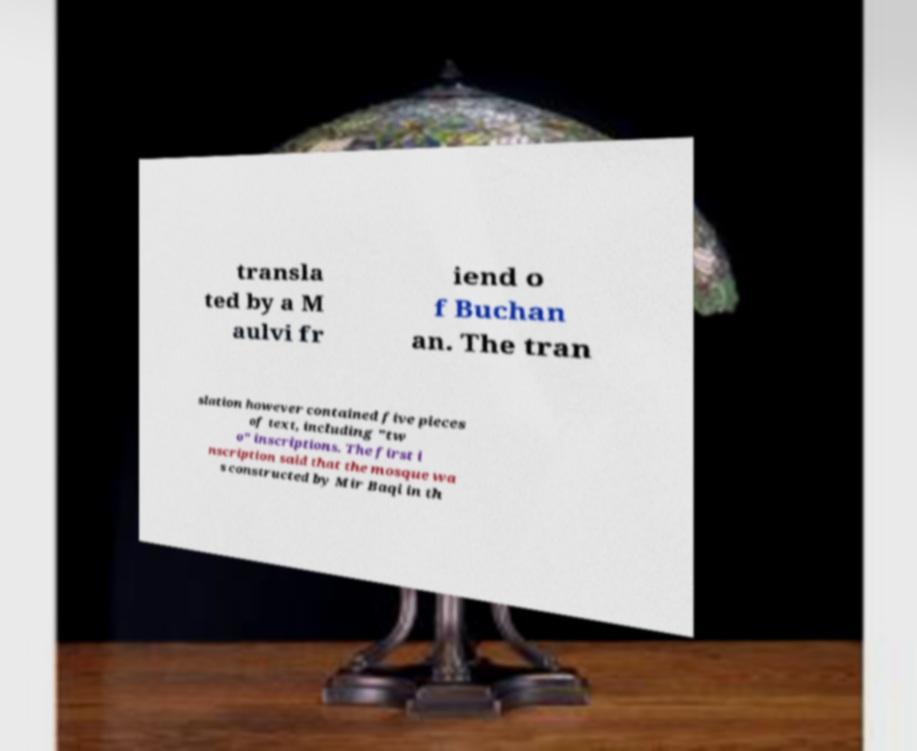Could you extract and type out the text from this image? transla ted by a M aulvi fr iend o f Buchan an. The tran slation however contained five pieces of text, including "tw o" inscriptions. The first i nscription said that the mosque wa s constructed by Mir Baqi in th 